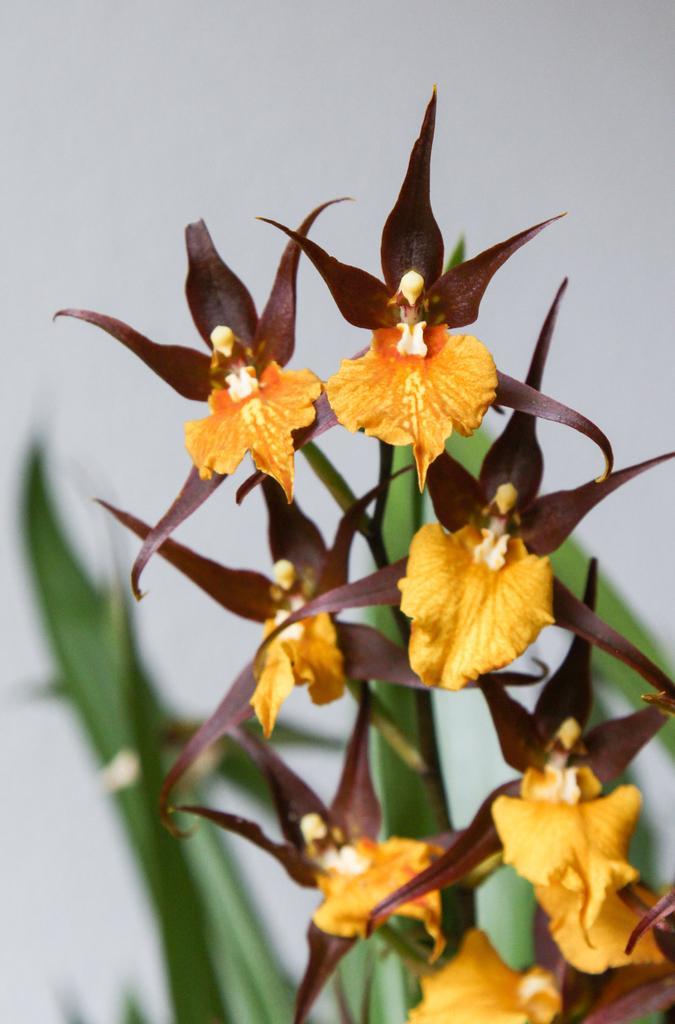How would you summarize this image in a sentence or two? In the image we can see a plant and flowers. The flowers are yellow and brown in color, and the background is blurred. 